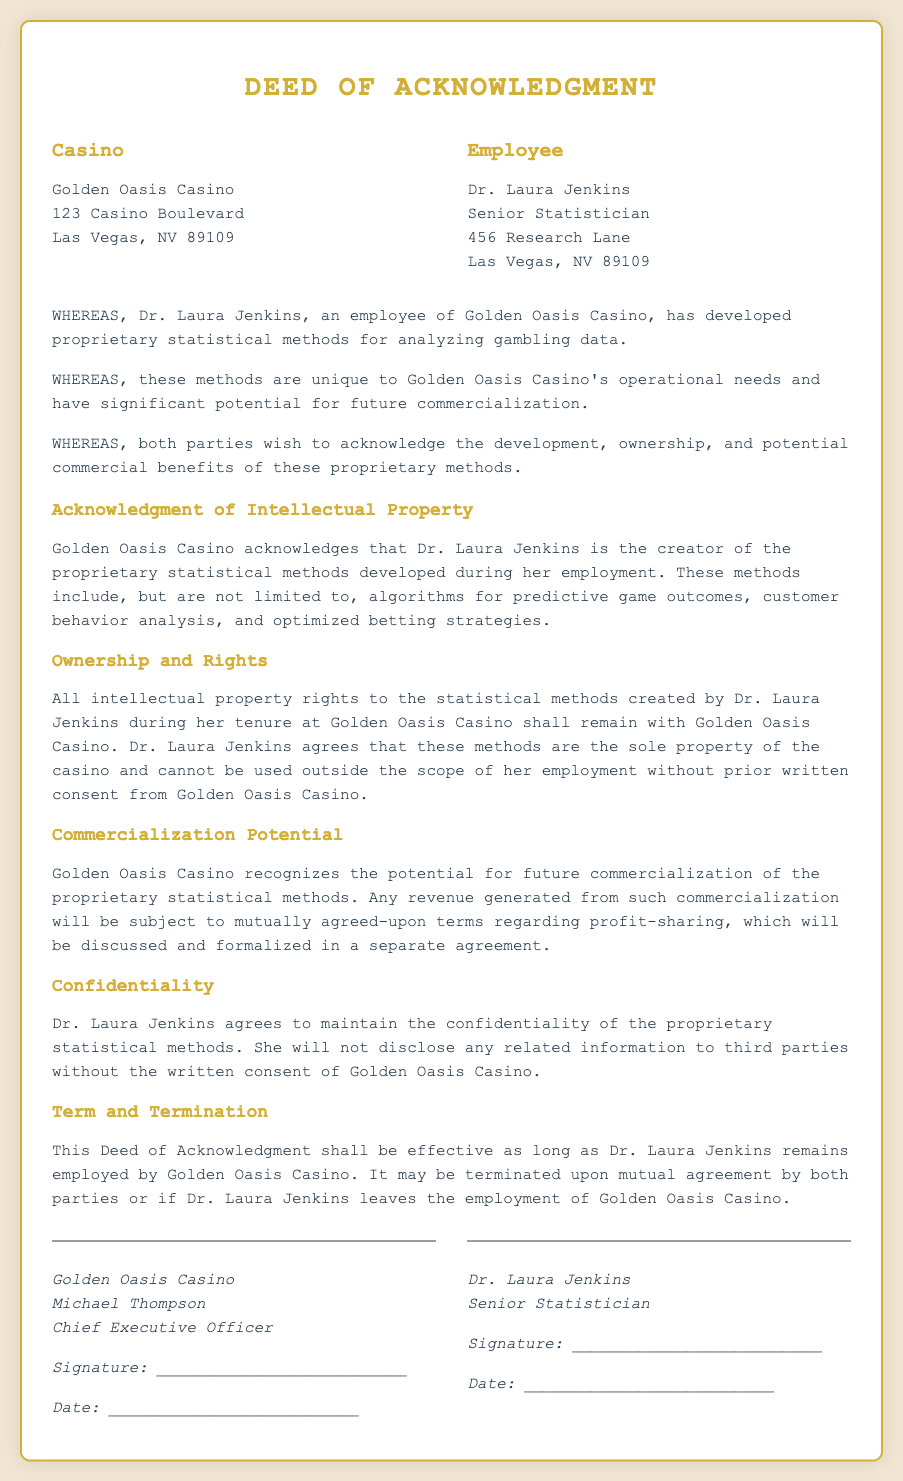What is the name of the casino? The name of the casino is stated in the document as Golden Oasis Casino.
Answer: Golden Oasis Casino Who is the employee acknowledged in the deed? The employee acknowledged in the deed is explicitly named as Dr. Laura Jenkins.
Answer: Dr. Laura Jenkins What is Dr. Laura Jenkins's role at the casino? The role of Dr. Laura Jenkins at the casino is specified as Senior Statistician.
Answer: Senior Statistician What type of statistical methods did Dr. Laura Jenkins develop? The document mentions proprietary statistical methods for analyzing gambling data developed by Dr. Laura Jenkins.
Answer: Proprietary statistical methods What rights does Golden Oasis Casino retain? The document states that Golden Oasis Casino retains the intellectual property rights to the statistical methods created by Dr. Laura Jenkins.
Answer: Intellectual property rights What is required for Dr. Laura Jenkins to use the methods outside her employment? The deed specifies that Dr. Laura Jenkins must obtain prior written consent from Golden Oasis Casino to use the methods outside her employment.
Answer: Prior written consent What is the potential mentioned for the statistical methods? The document highlights the potential for future commercialization of the proprietary statistical methods.
Answer: Future commercialization How long is the Deed of Acknowledgment effective? The deed states it shall be effective as long as Dr. Laura Jenkins remains employed by Golden Oasis Casino.
Answer: While employed Who signed the deed on behalf of the casino? The document identifies Michael Thompson as the signatory on behalf of the casino.
Answer: Michael Thompson 